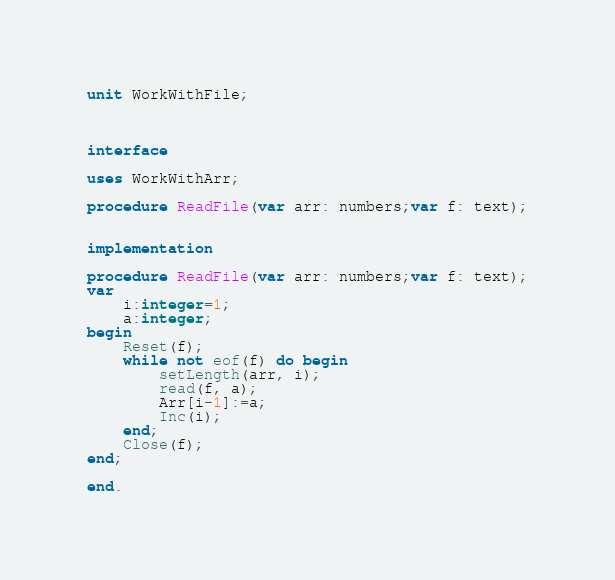Convert code to text. <code><loc_0><loc_0><loc_500><loc_500><_Pascal_>unit WorkWithFile;

 

interface

uses WorkWithArr;

procedure ReadFile(var arr: numbers;var f: text);
    

implementation

procedure ReadFile(var arr: numbers;var f: text);
var 
    i:integer=1;
    a:integer;
begin
    Reset(f);
    while not eof(f) do begin
        setLength(arr, i);
        read(f, a);
        Arr[i-1]:=a;
        Inc(i);
    end;
    Close(f);
end;

end.</code> 